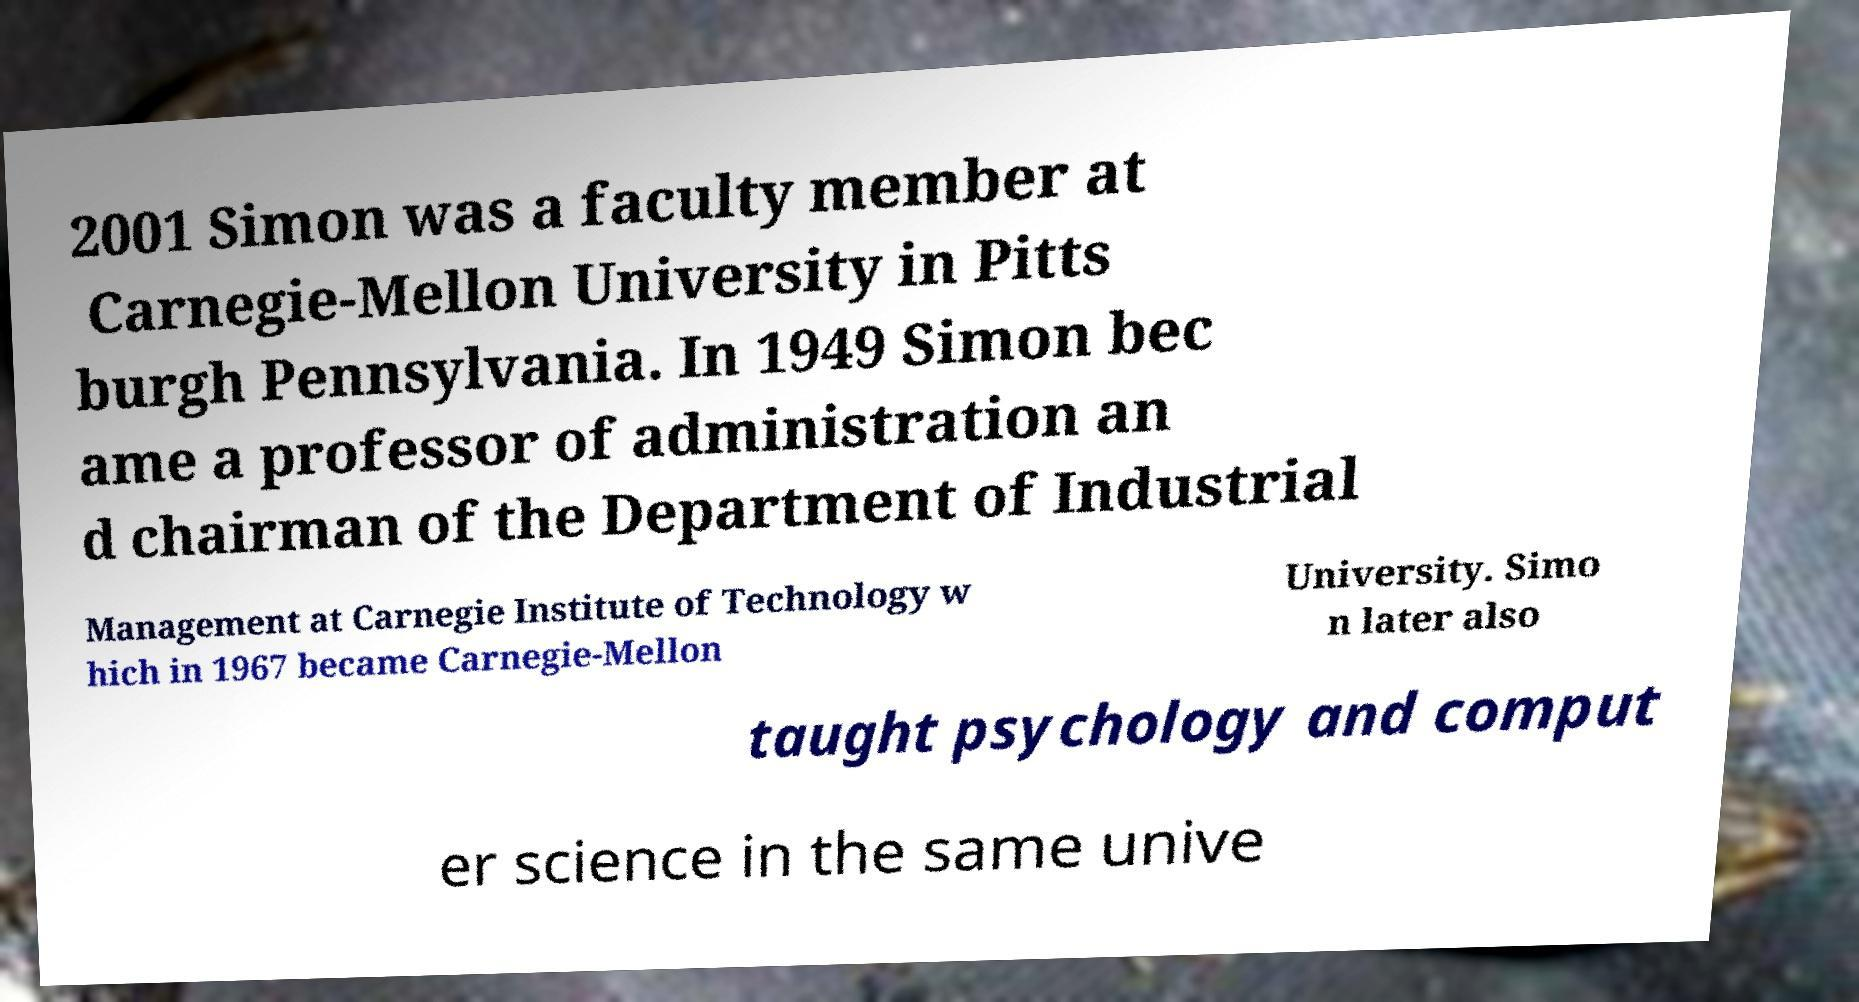Can you read and provide the text displayed in the image?This photo seems to have some interesting text. Can you extract and type it out for me? 2001 Simon was a faculty member at Carnegie-Mellon University in Pitts burgh Pennsylvania. In 1949 Simon bec ame a professor of administration an d chairman of the Department of Industrial Management at Carnegie Institute of Technology w hich in 1967 became Carnegie-Mellon University. Simo n later also taught psychology and comput er science in the same unive 